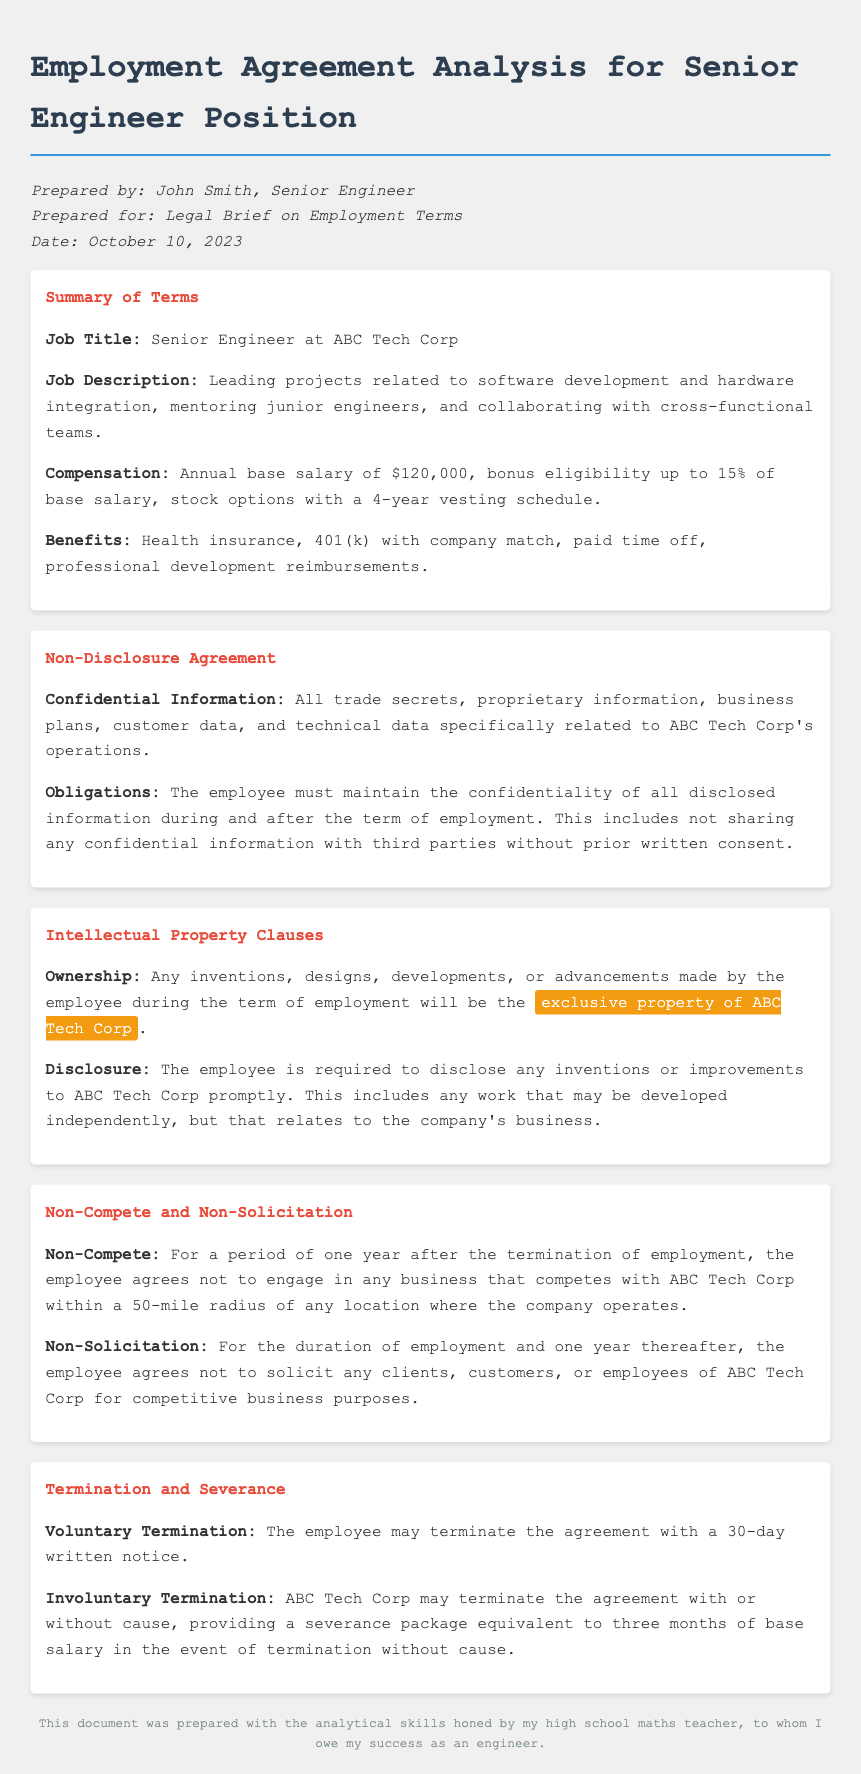What is the job title? The job title is specified in the summary section of the document.
Answer: Senior Engineer at ABC Tech Corp What is the annual base salary? The annual base salary is described in the compensation section of the document.
Answer: $120,000 What is the non-disclosure obligation during employment? The non-disclosure agreement outlines the employee's obligation regarding confidential information.
Answer: Maintain confidentiality What is the duration of the non-compete agreement? The non-compete period is mentioned in the non-compete and non-solicitation section of the document.
Answer: One year What is the severance package for involuntary termination? The termination and severance section provides details about the severance package.
Answer: Three months of base salary What types of information are considered confidential? The non-disclosure agreement lists various types of confidential information.
Answer: Trade secrets and proprietary information What is required of the employee regarding inventions? The intellectual property clauses detail the employee's responsibilities about inventions made during employment.
Answer: Disclosure of inventions What happens upon voluntary termination? The termination section specifies the procedure for voluntary termination.
Answer: 30-day written notice What is the eligibility for bonuses? The compensation section states conditions for bonuses.
Answer: Up to 15% of base salary 